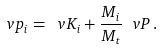<formula> <loc_0><loc_0><loc_500><loc_500>\ v p _ { i } = \ v K _ { i } + \frac { M _ { i } } { M _ { t } } \ v P \, .</formula> 